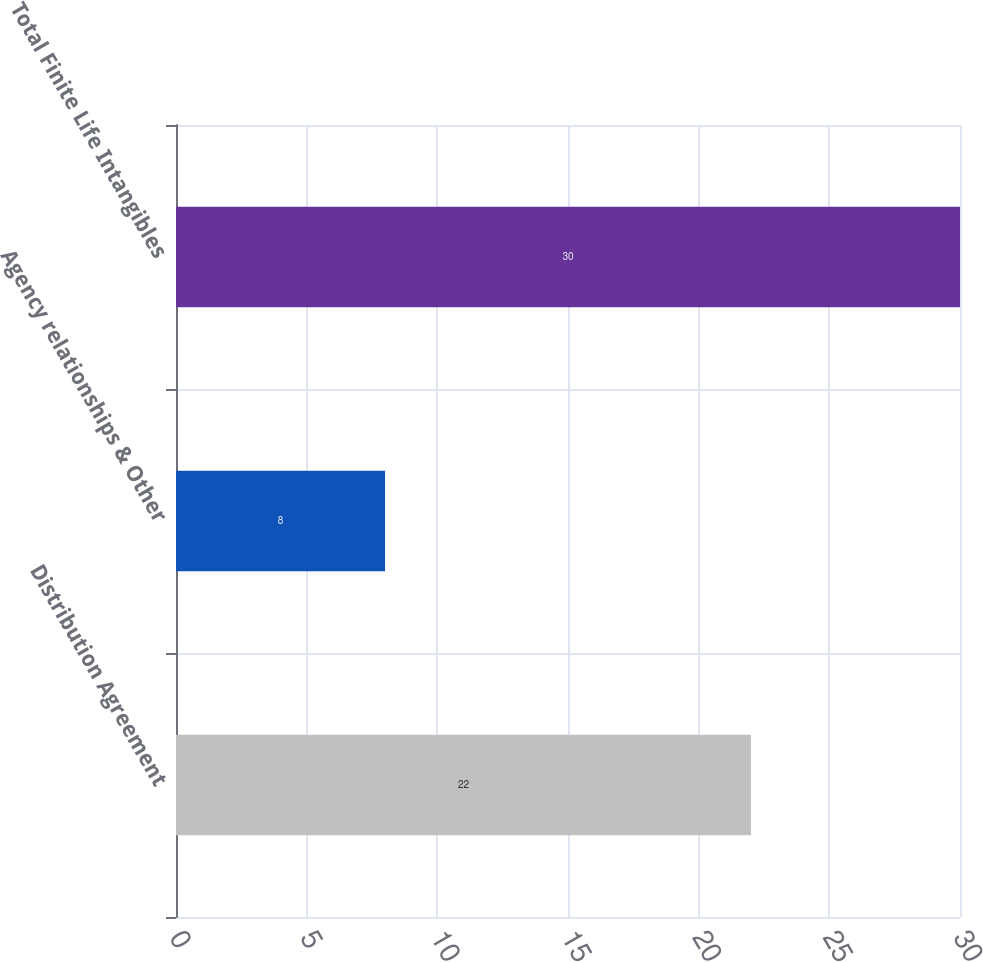Convert chart to OTSL. <chart><loc_0><loc_0><loc_500><loc_500><bar_chart><fcel>Distribution Agreement<fcel>Agency relationships & Other<fcel>Total Finite Life Intangibles<nl><fcel>22<fcel>8<fcel>30<nl></chart> 